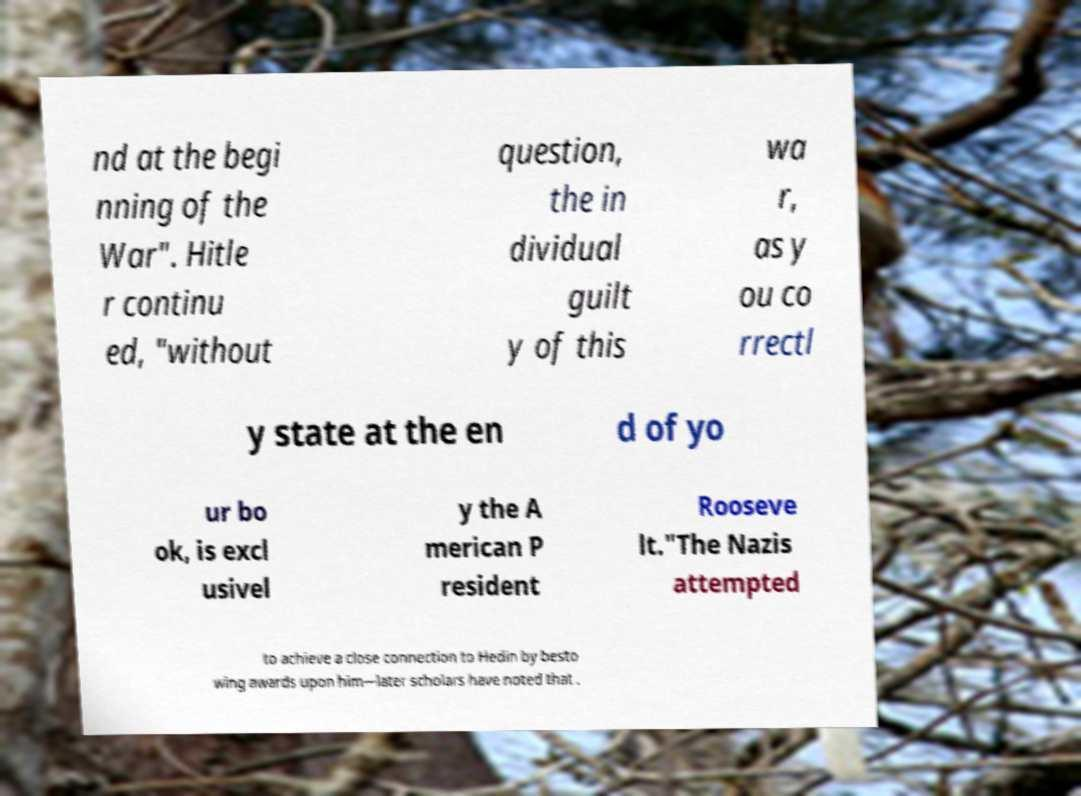What messages or text are displayed in this image? I need them in a readable, typed format. nd at the begi nning of the War". Hitle r continu ed, "without question, the in dividual guilt y of this wa r, as y ou co rrectl y state at the en d of yo ur bo ok, is excl usivel y the A merican P resident Rooseve lt."The Nazis attempted to achieve a close connection to Hedin by besto wing awards upon him—later scholars have noted that . 